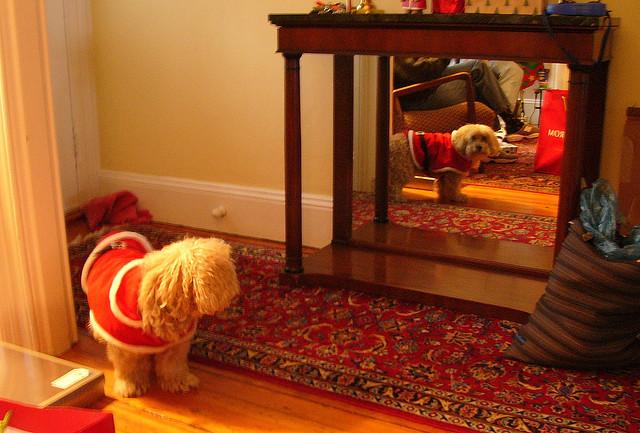What breed of dog?
Answer briefly. Poodle. What is the dog wearing?
Short answer required. Santa suit. Is the dog admiring himself in the mirror?
Give a very brief answer. Yes. 